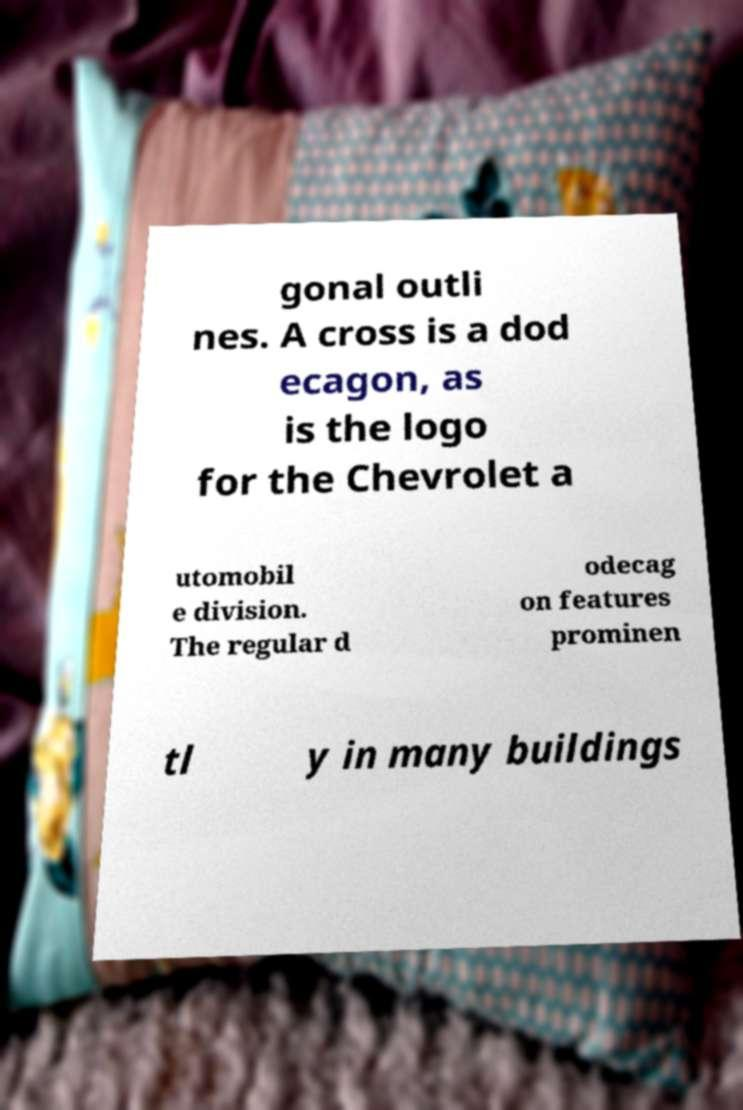Could you assist in decoding the text presented in this image and type it out clearly? gonal outli nes. A cross is a dod ecagon, as is the logo for the Chevrolet a utomobil e division. The regular d odecag on features prominen tl y in many buildings 